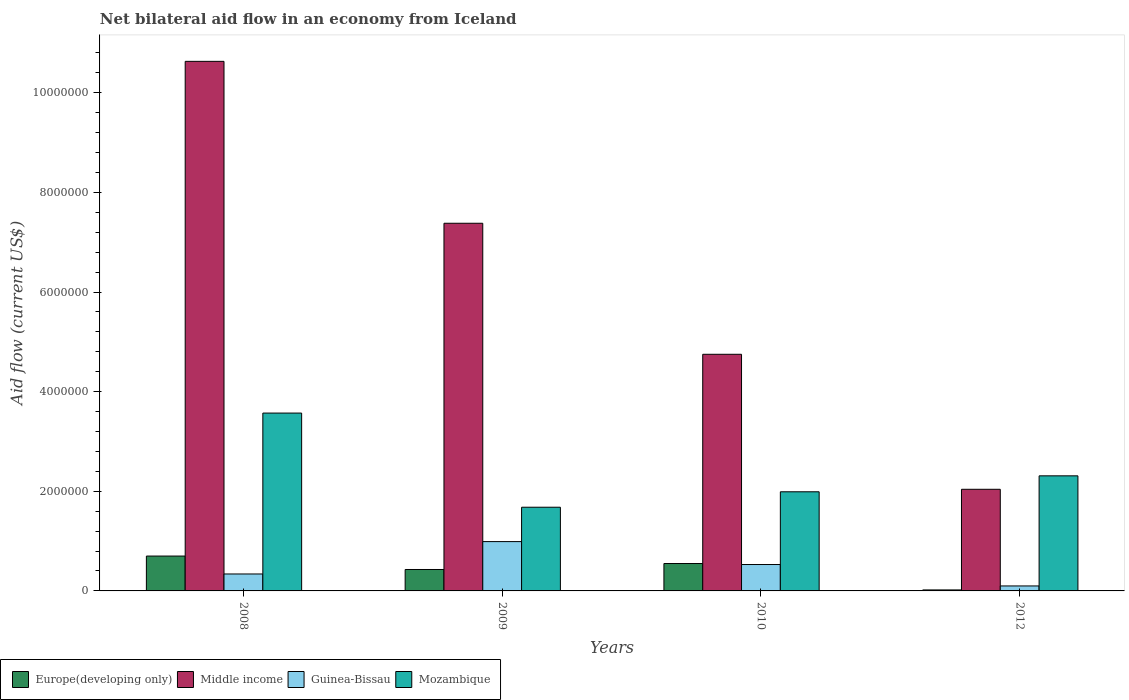How many different coloured bars are there?
Provide a short and direct response. 4. Are the number of bars per tick equal to the number of legend labels?
Provide a short and direct response. Yes. Are the number of bars on each tick of the X-axis equal?
Provide a short and direct response. Yes. How many bars are there on the 3rd tick from the right?
Provide a short and direct response. 4. In how many cases, is the number of bars for a given year not equal to the number of legend labels?
Make the answer very short. 0. What is the net bilateral aid flow in Middle income in 2010?
Your answer should be very brief. 4.75e+06. Across all years, what is the maximum net bilateral aid flow in Middle income?
Provide a short and direct response. 1.06e+07. Across all years, what is the minimum net bilateral aid flow in Mozambique?
Your answer should be compact. 1.68e+06. In which year was the net bilateral aid flow in Middle income maximum?
Give a very brief answer. 2008. In which year was the net bilateral aid flow in Mozambique minimum?
Keep it short and to the point. 2009. What is the total net bilateral aid flow in Mozambique in the graph?
Your answer should be compact. 9.55e+06. What is the difference between the net bilateral aid flow in Mozambique in 2009 and that in 2010?
Keep it short and to the point. -3.10e+05. What is the difference between the net bilateral aid flow in Europe(developing only) in 2008 and the net bilateral aid flow in Guinea-Bissau in 2010?
Ensure brevity in your answer.  1.70e+05. What is the average net bilateral aid flow in Middle income per year?
Provide a short and direct response. 6.20e+06. In the year 2009, what is the difference between the net bilateral aid flow in Middle income and net bilateral aid flow in Mozambique?
Offer a very short reply. 5.70e+06. In how many years, is the net bilateral aid flow in Guinea-Bissau greater than 4000000 US$?
Offer a very short reply. 0. What is the ratio of the net bilateral aid flow in Europe(developing only) in 2008 to that in 2010?
Ensure brevity in your answer.  1.27. Is the net bilateral aid flow in Mozambique in 2009 less than that in 2012?
Keep it short and to the point. Yes. Is the difference between the net bilateral aid flow in Middle income in 2009 and 2012 greater than the difference between the net bilateral aid flow in Mozambique in 2009 and 2012?
Ensure brevity in your answer.  Yes. What is the difference between the highest and the lowest net bilateral aid flow in Europe(developing only)?
Your answer should be very brief. 6.80e+05. Is the sum of the net bilateral aid flow in Guinea-Bissau in 2008 and 2010 greater than the maximum net bilateral aid flow in Europe(developing only) across all years?
Offer a terse response. Yes. Is it the case that in every year, the sum of the net bilateral aid flow in Guinea-Bissau and net bilateral aid flow in Europe(developing only) is greater than the sum of net bilateral aid flow in Middle income and net bilateral aid flow in Mozambique?
Keep it short and to the point. No. What does the 1st bar from the left in 2008 represents?
Make the answer very short. Europe(developing only). What does the 4th bar from the right in 2010 represents?
Give a very brief answer. Europe(developing only). Is it the case that in every year, the sum of the net bilateral aid flow in Mozambique and net bilateral aid flow in Guinea-Bissau is greater than the net bilateral aid flow in Europe(developing only)?
Give a very brief answer. Yes. How many bars are there?
Your answer should be compact. 16. What is the difference between two consecutive major ticks on the Y-axis?
Make the answer very short. 2.00e+06. Does the graph contain grids?
Make the answer very short. No. Where does the legend appear in the graph?
Keep it short and to the point. Bottom left. How are the legend labels stacked?
Your answer should be compact. Horizontal. What is the title of the graph?
Ensure brevity in your answer.  Net bilateral aid flow in an economy from Iceland. Does "Syrian Arab Republic" appear as one of the legend labels in the graph?
Offer a very short reply. No. What is the Aid flow (current US$) of Europe(developing only) in 2008?
Give a very brief answer. 7.00e+05. What is the Aid flow (current US$) in Middle income in 2008?
Keep it short and to the point. 1.06e+07. What is the Aid flow (current US$) in Guinea-Bissau in 2008?
Ensure brevity in your answer.  3.40e+05. What is the Aid flow (current US$) in Mozambique in 2008?
Provide a short and direct response. 3.57e+06. What is the Aid flow (current US$) in Europe(developing only) in 2009?
Keep it short and to the point. 4.30e+05. What is the Aid flow (current US$) in Middle income in 2009?
Make the answer very short. 7.38e+06. What is the Aid flow (current US$) of Guinea-Bissau in 2009?
Offer a very short reply. 9.90e+05. What is the Aid flow (current US$) of Mozambique in 2009?
Offer a very short reply. 1.68e+06. What is the Aid flow (current US$) in Middle income in 2010?
Your answer should be compact. 4.75e+06. What is the Aid flow (current US$) of Guinea-Bissau in 2010?
Keep it short and to the point. 5.30e+05. What is the Aid flow (current US$) in Mozambique in 2010?
Offer a terse response. 1.99e+06. What is the Aid flow (current US$) of Europe(developing only) in 2012?
Offer a very short reply. 2.00e+04. What is the Aid flow (current US$) of Middle income in 2012?
Offer a terse response. 2.04e+06. What is the Aid flow (current US$) of Mozambique in 2012?
Keep it short and to the point. 2.31e+06. Across all years, what is the maximum Aid flow (current US$) of Middle income?
Make the answer very short. 1.06e+07. Across all years, what is the maximum Aid flow (current US$) of Guinea-Bissau?
Your response must be concise. 9.90e+05. Across all years, what is the maximum Aid flow (current US$) in Mozambique?
Offer a very short reply. 3.57e+06. Across all years, what is the minimum Aid flow (current US$) of Middle income?
Offer a terse response. 2.04e+06. Across all years, what is the minimum Aid flow (current US$) in Mozambique?
Provide a short and direct response. 1.68e+06. What is the total Aid flow (current US$) of Europe(developing only) in the graph?
Your answer should be very brief. 1.70e+06. What is the total Aid flow (current US$) of Middle income in the graph?
Offer a very short reply. 2.48e+07. What is the total Aid flow (current US$) of Guinea-Bissau in the graph?
Offer a terse response. 1.96e+06. What is the total Aid flow (current US$) in Mozambique in the graph?
Your answer should be compact. 9.55e+06. What is the difference between the Aid flow (current US$) in Middle income in 2008 and that in 2009?
Provide a short and direct response. 3.25e+06. What is the difference between the Aid flow (current US$) of Guinea-Bissau in 2008 and that in 2009?
Ensure brevity in your answer.  -6.50e+05. What is the difference between the Aid flow (current US$) in Mozambique in 2008 and that in 2009?
Provide a short and direct response. 1.89e+06. What is the difference between the Aid flow (current US$) of Middle income in 2008 and that in 2010?
Provide a short and direct response. 5.88e+06. What is the difference between the Aid flow (current US$) of Mozambique in 2008 and that in 2010?
Keep it short and to the point. 1.58e+06. What is the difference between the Aid flow (current US$) of Europe(developing only) in 2008 and that in 2012?
Offer a terse response. 6.80e+05. What is the difference between the Aid flow (current US$) of Middle income in 2008 and that in 2012?
Make the answer very short. 8.59e+06. What is the difference between the Aid flow (current US$) of Mozambique in 2008 and that in 2012?
Give a very brief answer. 1.26e+06. What is the difference between the Aid flow (current US$) of Middle income in 2009 and that in 2010?
Your response must be concise. 2.63e+06. What is the difference between the Aid flow (current US$) of Guinea-Bissau in 2009 and that in 2010?
Offer a terse response. 4.60e+05. What is the difference between the Aid flow (current US$) of Mozambique in 2009 and that in 2010?
Your answer should be very brief. -3.10e+05. What is the difference between the Aid flow (current US$) of Middle income in 2009 and that in 2012?
Provide a succinct answer. 5.34e+06. What is the difference between the Aid flow (current US$) in Guinea-Bissau in 2009 and that in 2012?
Provide a short and direct response. 8.90e+05. What is the difference between the Aid flow (current US$) of Mozambique in 2009 and that in 2012?
Provide a short and direct response. -6.30e+05. What is the difference between the Aid flow (current US$) in Europe(developing only) in 2010 and that in 2012?
Your response must be concise. 5.30e+05. What is the difference between the Aid flow (current US$) in Middle income in 2010 and that in 2012?
Keep it short and to the point. 2.71e+06. What is the difference between the Aid flow (current US$) of Guinea-Bissau in 2010 and that in 2012?
Give a very brief answer. 4.30e+05. What is the difference between the Aid flow (current US$) of Mozambique in 2010 and that in 2012?
Provide a succinct answer. -3.20e+05. What is the difference between the Aid flow (current US$) of Europe(developing only) in 2008 and the Aid flow (current US$) of Middle income in 2009?
Offer a terse response. -6.68e+06. What is the difference between the Aid flow (current US$) of Europe(developing only) in 2008 and the Aid flow (current US$) of Mozambique in 2009?
Ensure brevity in your answer.  -9.80e+05. What is the difference between the Aid flow (current US$) of Middle income in 2008 and the Aid flow (current US$) of Guinea-Bissau in 2009?
Provide a short and direct response. 9.64e+06. What is the difference between the Aid flow (current US$) in Middle income in 2008 and the Aid flow (current US$) in Mozambique in 2009?
Ensure brevity in your answer.  8.95e+06. What is the difference between the Aid flow (current US$) in Guinea-Bissau in 2008 and the Aid flow (current US$) in Mozambique in 2009?
Provide a succinct answer. -1.34e+06. What is the difference between the Aid flow (current US$) in Europe(developing only) in 2008 and the Aid flow (current US$) in Middle income in 2010?
Keep it short and to the point. -4.05e+06. What is the difference between the Aid flow (current US$) in Europe(developing only) in 2008 and the Aid flow (current US$) in Guinea-Bissau in 2010?
Your answer should be very brief. 1.70e+05. What is the difference between the Aid flow (current US$) of Europe(developing only) in 2008 and the Aid flow (current US$) of Mozambique in 2010?
Provide a short and direct response. -1.29e+06. What is the difference between the Aid flow (current US$) in Middle income in 2008 and the Aid flow (current US$) in Guinea-Bissau in 2010?
Provide a short and direct response. 1.01e+07. What is the difference between the Aid flow (current US$) of Middle income in 2008 and the Aid flow (current US$) of Mozambique in 2010?
Make the answer very short. 8.64e+06. What is the difference between the Aid flow (current US$) in Guinea-Bissau in 2008 and the Aid flow (current US$) in Mozambique in 2010?
Provide a succinct answer. -1.65e+06. What is the difference between the Aid flow (current US$) in Europe(developing only) in 2008 and the Aid flow (current US$) in Middle income in 2012?
Make the answer very short. -1.34e+06. What is the difference between the Aid flow (current US$) of Europe(developing only) in 2008 and the Aid flow (current US$) of Guinea-Bissau in 2012?
Your answer should be very brief. 6.00e+05. What is the difference between the Aid flow (current US$) of Europe(developing only) in 2008 and the Aid flow (current US$) of Mozambique in 2012?
Provide a short and direct response. -1.61e+06. What is the difference between the Aid flow (current US$) in Middle income in 2008 and the Aid flow (current US$) in Guinea-Bissau in 2012?
Your response must be concise. 1.05e+07. What is the difference between the Aid flow (current US$) of Middle income in 2008 and the Aid flow (current US$) of Mozambique in 2012?
Offer a terse response. 8.32e+06. What is the difference between the Aid flow (current US$) of Guinea-Bissau in 2008 and the Aid flow (current US$) of Mozambique in 2012?
Give a very brief answer. -1.97e+06. What is the difference between the Aid flow (current US$) of Europe(developing only) in 2009 and the Aid flow (current US$) of Middle income in 2010?
Offer a terse response. -4.32e+06. What is the difference between the Aid flow (current US$) in Europe(developing only) in 2009 and the Aid flow (current US$) in Guinea-Bissau in 2010?
Keep it short and to the point. -1.00e+05. What is the difference between the Aid flow (current US$) in Europe(developing only) in 2009 and the Aid flow (current US$) in Mozambique in 2010?
Provide a short and direct response. -1.56e+06. What is the difference between the Aid flow (current US$) of Middle income in 2009 and the Aid flow (current US$) of Guinea-Bissau in 2010?
Your answer should be very brief. 6.85e+06. What is the difference between the Aid flow (current US$) of Middle income in 2009 and the Aid flow (current US$) of Mozambique in 2010?
Provide a short and direct response. 5.39e+06. What is the difference between the Aid flow (current US$) in Guinea-Bissau in 2009 and the Aid flow (current US$) in Mozambique in 2010?
Provide a succinct answer. -1.00e+06. What is the difference between the Aid flow (current US$) in Europe(developing only) in 2009 and the Aid flow (current US$) in Middle income in 2012?
Keep it short and to the point. -1.61e+06. What is the difference between the Aid flow (current US$) in Europe(developing only) in 2009 and the Aid flow (current US$) in Guinea-Bissau in 2012?
Your answer should be very brief. 3.30e+05. What is the difference between the Aid flow (current US$) of Europe(developing only) in 2009 and the Aid flow (current US$) of Mozambique in 2012?
Keep it short and to the point. -1.88e+06. What is the difference between the Aid flow (current US$) of Middle income in 2009 and the Aid flow (current US$) of Guinea-Bissau in 2012?
Ensure brevity in your answer.  7.28e+06. What is the difference between the Aid flow (current US$) in Middle income in 2009 and the Aid flow (current US$) in Mozambique in 2012?
Your answer should be compact. 5.07e+06. What is the difference between the Aid flow (current US$) in Guinea-Bissau in 2009 and the Aid flow (current US$) in Mozambique in 2012?
Ensure brevity in your answer.  -1.32e+06. What is the difference between the Aid flow (current US$) in Europe(developing only) in 2010 and the Aid flow (current US$) in Middle income in 2012?
Your response must be concise. -1.49e+06. What is the difference between the Aid flow (current US$) in Europe(developing only) in 2010 and the Aid flow (current US$) in Guinea-Bissau in 2012?
Your answer should be very brief. 4.50e+05. What is the difference between the Aid flow (current US$) of Europe(developing only) in 2010 and the Aid flow (current US$) of Mozambique in 2012?
Provide a succinct answer. -1.76e+06. What is the difference between the Aid flow (current US$) of Middle income in 2010 and the Aid flow (current US$) of Guinea-Bissau in 2012?
Give a very brief answer. 4.65e+06. What is the difference between the Aid flow (current US$) in Middle income in 2010 and the Aid flow (current US$) in Mozambique in 2012?
Provide a succinct answer. 2.44e+06. What is the difference between the Aid flow (current US$) in Guinea-Bissau in 2010 and the Aid flow (current US$) in Mozambique in 2012?
Keep it short and to the point. -1.78e+06. What is the average Aid flow (current US$) of Europe(developing only) per year?
Give a very brief answer. 4.25e+05. What is the average Aid flow (current US$) of Middle income per year?
Provide a succinct answer. 6.20e+06. What is the average Aid flow (current US$) in Guinea-Bissau per year?
Give a very brief answer. 4.90e+05. What is the average Aid flow (current US$) of Mozambique per year?
Make the answer very short. 2.39e+06. In the year 2008, what is the difference between the Aid flow (current US$) in Europe(developing only) and Aid flow (current US$) in Middle income?
Provide a succinct answer. -9.93e+06. In the year 2008, what is the difference between the Aid flow (current US$) of Europe(developing only) and Aid flow (current US$) of Mozambique?
Your answer should be compact. -2.87e+06. In the year 2008, what is the difference between the Aid flow (current US$) of Middle income and Aid flow (current US$) of Guinea-Bissau?
Your answer should be very brief. 1.03e+07. In the year 2008, what is the difference between the Aid flow (current US$) in Middle income and Aid flow (current US$) in Mozambique?
Your answer should be very brief. 7.06e+06. In the year 2008, what is the difference between the Aid flow (current US$) of Guinea-Bissau and Aid flow (current US$) of Mozambique?
Your answer should be compact. -3.23e+06. In the year 2009, what is the difference between the Aid flow (current US$) in Europe(developing only) and Aid flow (current US$) in Middle income?
Your response must be concise. -6.95e+06. In the year 2009, what is the difference between the Aid flow (current US$) of Europe(developing only) and Aid flow (current US$) of Guinea-Bissau?
Give a very brief answer. -5.60e+05. In the year 2009, what is the difference between the Aid flow (current US$) in Europe(developing only) and Aid flow (current US$) in Mozambique?
Give a very brief answer. -1.25e+06. In the year 2009, what is the difference between the Aid flow (current US$) in Middle income and Aid flow (current US$) in Guinea-Bissau?
Your answer should be very brief. 6.39e+06. In the year 2009, what is the difference between the Aid flow (current US$) in Middle income and Aid flow (current US$) in Mozambique?
Make the answer very short. 5.70e+06. In the year 2009, what is the difference between the Aid flow (current US$) in Guinea-Bissau and Aid flow (current US$) in Mozambique?
Ensure brevity in your answer.  -6.90e+05. In the year 2010, what is the difference between the Aid flow (current US$) in Europe(developing only) and Aid flow (current US$) in Middle income?
Offer a very short reply. -4.20e+06. In the year 2010, what is the difference between the Aid flow (current US$) of Europe(developing only) and Aid flow (current US$) of Mozambique?
Keep it short and to the point. -1.44e+06. In the year 2010, what is the difference between the Aid flow (current US$) in Middle income and Aid flow (current US$) in Guinea-Bissau?
Give a very brief answer. 4.22e+06. In the year 2010, what is the difference between the Aid flow (current US$) in Middle income and Aid flow (current US$) in Mozambique?
Your answer should be very brief. 2.76e+06. In the year 2010, what is the difference between the Aid flow (current US$) of Guinea-Bissau and Aid flow (current US$) of Mozambique?
Keep it short and to the point. -1.46e+06. In the year 2012, what is the difference between the Aid flow (current US$) of Europe(developing only) and Aid flow (current US$) of Middle income?
Offer a very short reply. -2.02e+06. In the year 2012, what is the difference between the Aid flow (current US$) of Europe(developing only) and Aid flow (current US$) of Mozambique?
Your response must be concise. -2.29e+06. In the year 2012, what is the difference between the Aid flow (current US$) in Middle income and Aid flow (current US$) in Guinea-Bissau?
Your response must be concise. 1.94e+06. In the year 2012, what is the difference between the Aid flow (current US$) of Middle income and Aid flow (current US$) of Mozambique?
Provide a short and direct response. -2.70e+05. In the year 2012, what is the difference between the Aid flow (current US$) in Guinea-Bissau and Aid flow (current US$) in Mozambique?
Ensure brevity in your answer.  -2.21e+06. What is the ratio of the Aid flow (current US$) of Europe(developing only) in 2008 to that in 2009?
Your answer should be compact. 1.63. What is the ratio of the Aid flow (current US$) in Middle income in 2008 to that in 2009?
Offer a terse response. 1.44. What is the ratio of the Aid flow (current US$) of Guinea-Bissau in 2008 to that in 2009?
Give a very brief answer. 0.34. What is the ratio of the Aid flow (current US$) of Mozambique in 2008 to that in 2009?
Provide a short and direct response. 2.12. What is the ratio of the Aid flow (current US$) of Europe(developing only) in 2008 to that in 2010?
Offer a very short reply. 1.27. What is the ratio of the Aid flow (current US$) of Middle income in 2008 to that in 2010?
Offer a terse response. 2.24. What is the ratio of the Aid flow (current US$) in Guinea-Bissau in 2008 to that in 2010?
Give a very brief answer. 0.64. What is the ratio of the Aid flow (current US$) of Mozambique in 2008 to that in 2010?
Your answer should be compact. 1.79. What is the ratio of the Aid flow (current US$) in Middle income in 2008 to that in 2012?
Your answer should be compact. 5.21. What is the ratio of the Aid flow (current US$) in Guinea-Bissau in 2008 to that in 2012?
Offer a very short reply. 3.4. What is the ratio of the Aid flow (current US$) in Mozambique in 2008 to that in 2012?
Provide a short and direct response. 1.55. What is the ratio of the Aid flow (current US$) of Europe(developing only) in 2009 to that in 2010?
Give a very brief answer. 0.78. What is the ratio of the Aid flow (current US$) in Middle income in 2009 to that in 2010?
Your answer should be compact. 1.55. What is the ratio of the Aid flow (current US$) in Guinea-Bissau in 2009 to that in 2010?
Your response must be concise. 1.87. What is the ratio of the Aid flow (current US$) of Mozambique in 2009 to that in 2010?
Provide a short and direct response. 0.84. What is the ratio of the Aid flow (current US$) in Middle income in 2009 to that in 2012?
Offer a terse response. 3.62. What is the ratio of the Aid flow (current US$) of Mozambique in 2009 to that in 2012?
Make the answer very short. 0.73. What is the ratio of the Aid flow (current US$) of Europe(developing only) in 2010 to that in 2012?
Provide a succinct answer. 27.5. What is the ratio of the Aid flow (current US$) in Middle income in 2010 to that in 2012?
Your answer should be compact. 2.33. What is the ratio of the Aid flow (current US$) in Guinea-Bissau in 2010 to that in 2012?
Give a very brief answer. 5.3. What is the ratio of the Aid flow (current US$) in Mozambique in 2010 to that in 2012?
Ensure brevity in your answer.  0.86. What is the difference between the highest and the second highest Aid flow (current US$) in Middle income?
Ensure brevity in your answer.  3.25e+06. What is the difference between the highest and the second highest Aid flow (current US$) in Mozambique?
Ensure brevity in your answer.  1.26e+06. What is the difference between the highest and the lowest Aid flow (current US$) of Europe(developing only)?
Make the answer very short. 6.80e+05. What is the difference between the highest and the lowest Aid flow (current US$) of Middle income?
Ensure brevity in your answer.  8.59e+06. What is the difference between the highest and the lowest Aid flow (current US$) of Guinea-Bissau?
Your answer should be very brief. 8.90e+05. What is the difference between the highest and the lowest Aid flow (current US$) in Mozambique?
Make the answer very short. 1.89e+06. 